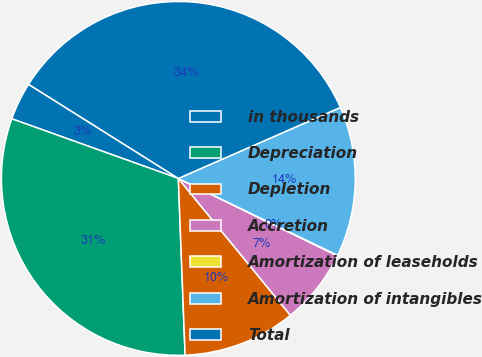Convert chart to OTSL. <chart><loc_0><loc_0><loc_500><loc_500><pie_chart><fcel>in thousands<fcel>Depreciation<fcel>Depletion<fcel>Accretion<fcel>Amortization of leaseholds<fcel>Amortization of intangibles<fcel>Total<nl><fcel>3.46%<fcel>31.08%<fcel>10.31%<fcel>6.88%<fcel>0.04%<fcel>13.73%<fcel>34.5%<nl></chart> 